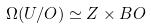Convert formula to latex. <formula><loc_0><loc_0><loc_500><loc_500>\Omega ( U / O ) \simeq Z \times B O</formula> 